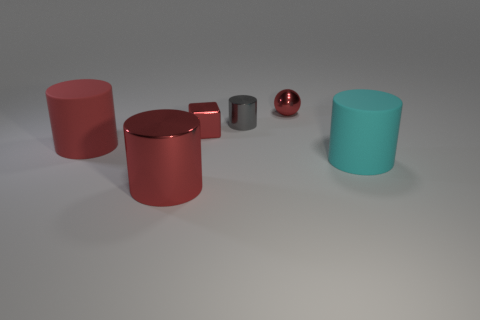Add 4 cyan rubber cubes. How many objects exist? 10 Subtract all spheres. How many objects are left? 5 Subtract 0 purple blocks. How many objects are left? 6 Subtract all big red metal things. Subtract all red metallic blocks. How many objects are left? 4 Add 6 big red things. How many big red things are left? 8 Add 1 big red matte cylinders. How many big red matte cylinders exist? 2 